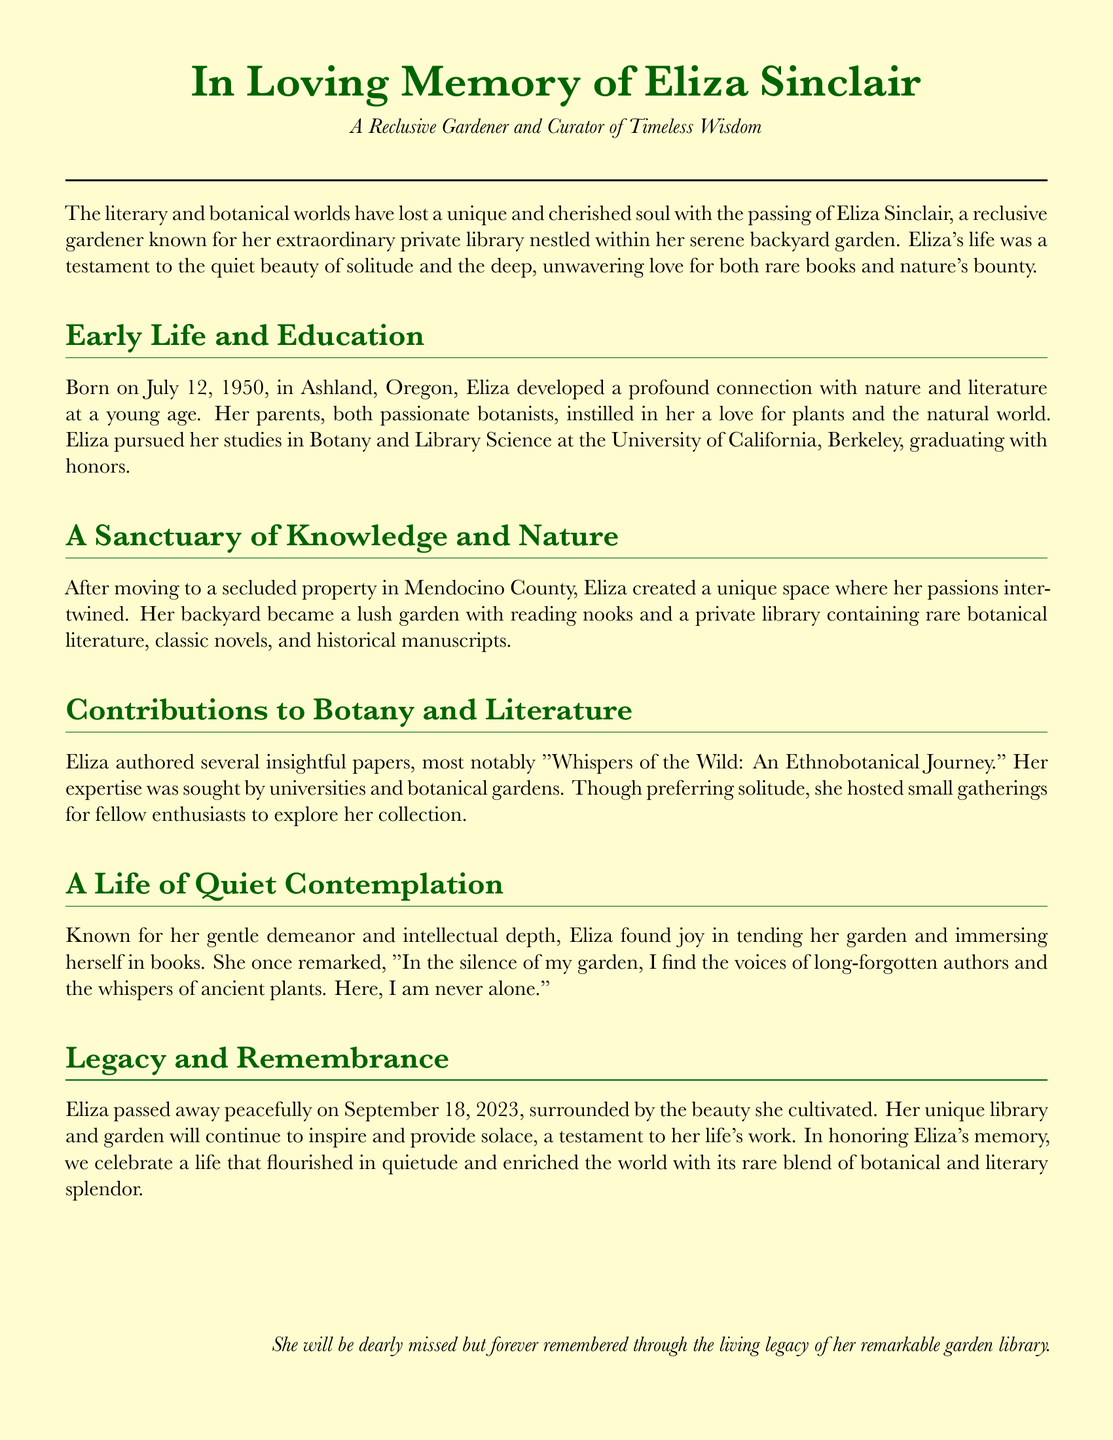What was Eliza's date of birth? The document explicitly states that Eliza was born on July 12, 1950.
Answer: July 12, 1950 In which county did Eliza create her private library? The document mentions that Eliza moved to a secluded property in Mendocino County.
Answer: Mendocino County What is the title of Eliza's notable paper? The document provides the title of her insightful paper as "Whispers of the Wild: An Ethnobotanical Journey."
Answer: Whispers of the Wild: An Ethnobotanical Journey When did Eliza pass away? The obituary states that Eliza passed away peacefully on September 18, 2023.
Answer: September 18, 2023 What were Eliza's fields of study? The document notes that Eliza pursued studies in Botany and Library Science.
Answer: Botany and Library Science How would Eliza's demeanor be described according to the document? The document describes Eliza as having a gentle demeanor and intellectual depth.
Answer: Gentle demeanor and intellectual depth What did Eliza believe she found in the silence of her garden? Eliza stated that she found the voices of long-forgotten authors and the whispers of ancient plants in her garden's silence.
Answer: The voices of long-forgotten authors and the whispers of ancient plants Which aspect of nature did Eliza cultivate in her life? The document highlights that Eliza cultivated a lush garden in her backyard.
Answer: A lush garden What serves as a testament to Eliza's life's work? The document mentions that Eliza's unique library and garden will continue to inspire as a testament to her life's work.
Answer: Her unique library and garden 